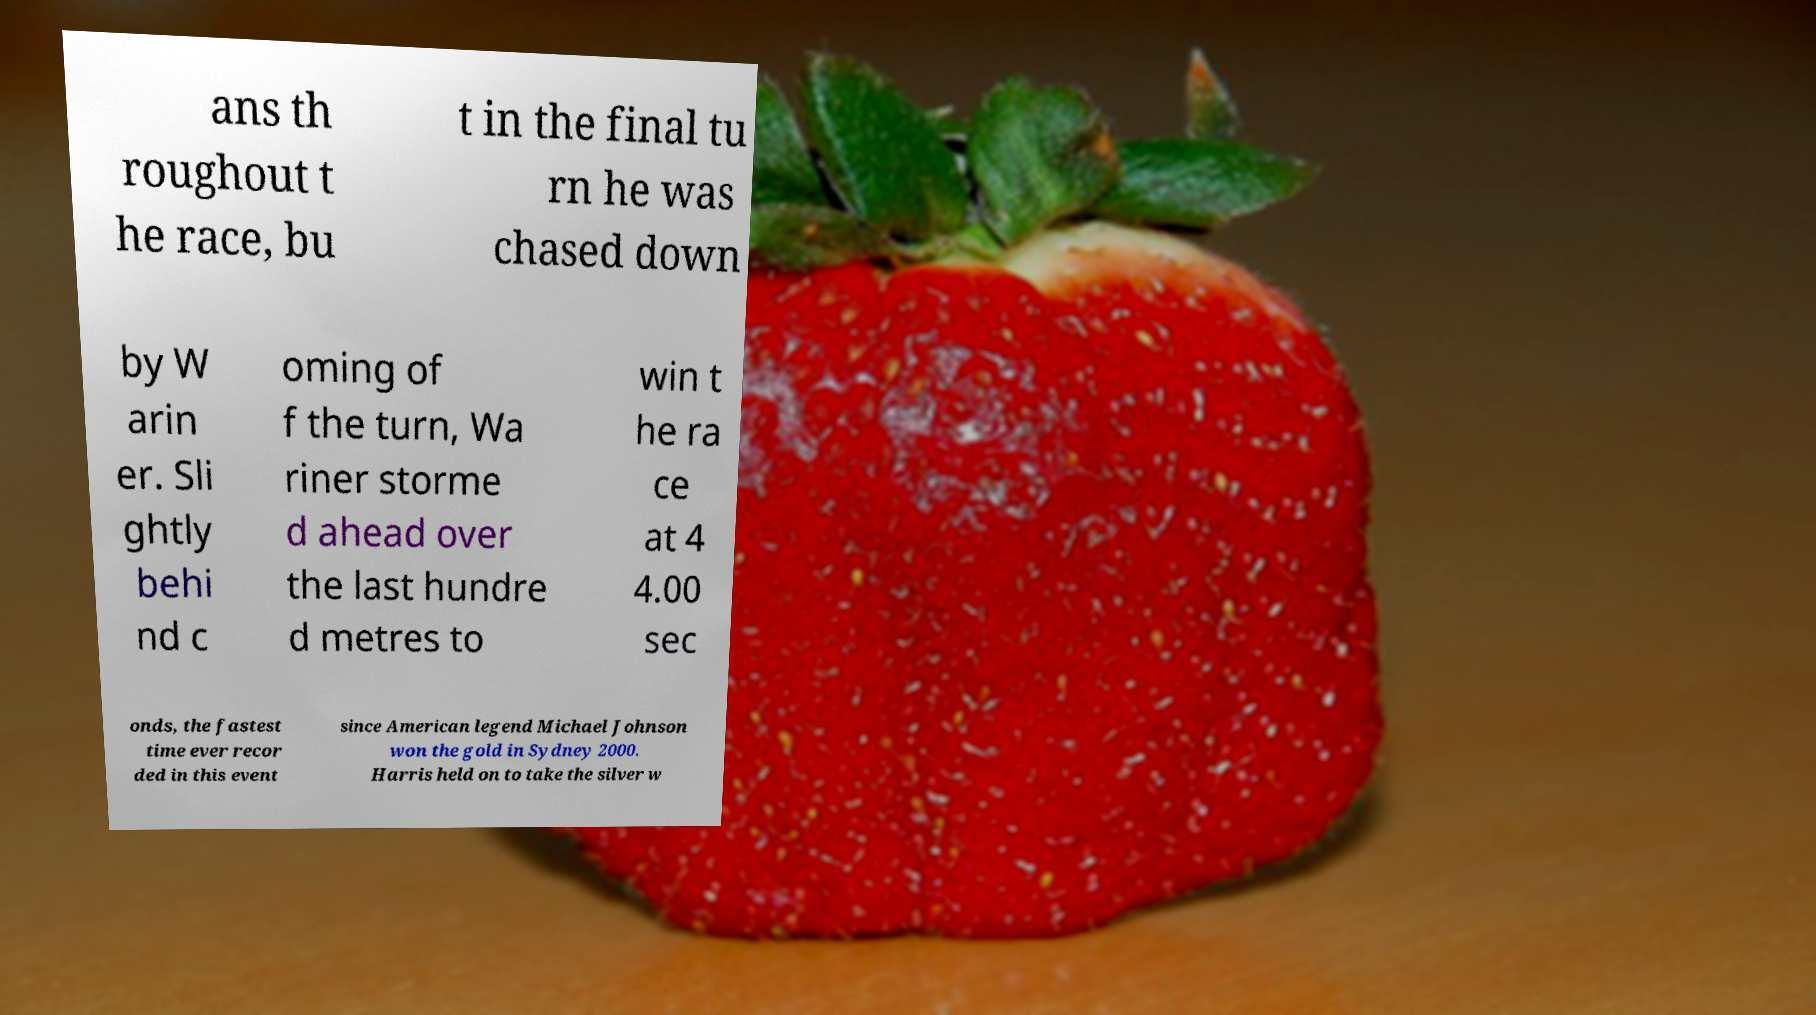Can you read and provide the text displayed in the image?This photo seems to have some interesting text. Can you extract and type it out for me? ans th roughout t he race, bu t in the final tu rn he was chased down by W arin er. Sli ghtly behi nd c oming of f the turn, Wa riner storme d ahead over the last hundre d metres to win t he ra ce at 4 4.00 sec onds, the fastest time ever recor ded in this event since American legend Michael Johnson won the gold in Sydney 2000. Harris held on to take the silver w 